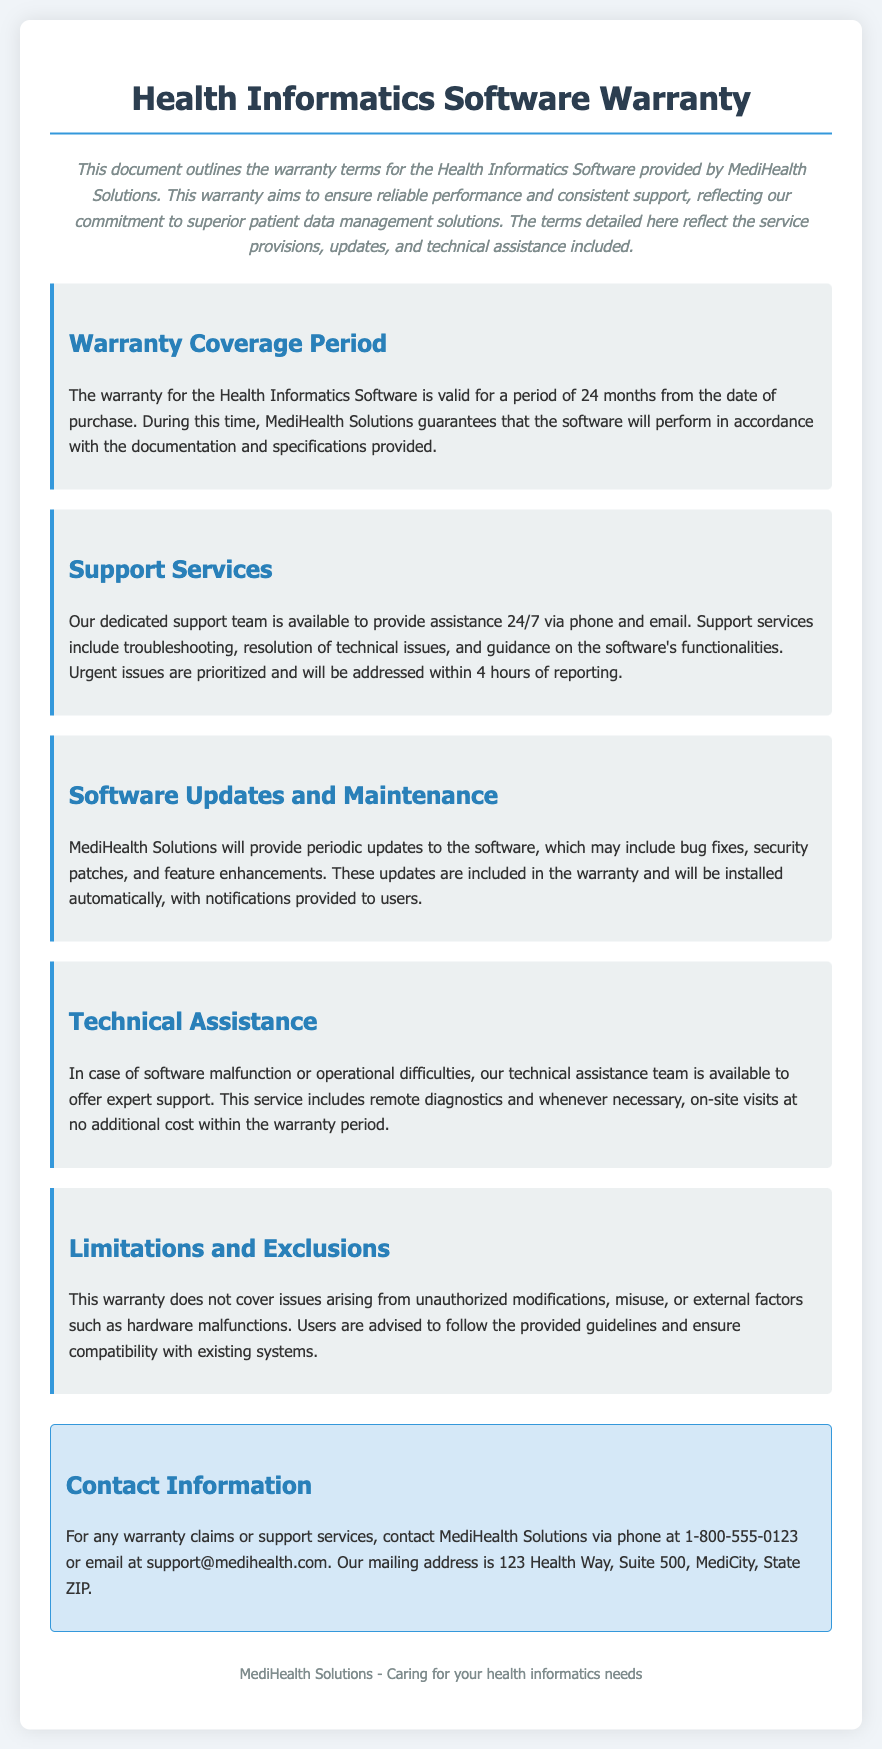what is the warranty coverage period? The warranty is valid for a period of 24 months from the date of purchase.
Answer: 24 months what type of support is available? The document states that support services include troubleshooting, resolution of technical issues, and guidance on the software's functionalities.
Answer: 24/7 support how quickly will urgent issues be addressed? Urgent issues are prioritized and will be addressed within 4 hours of reporting.
Answer: 4 hours what updates are included in the warranty? The warranty includes periodic updates that may consist of bug fixes, security patches, and feature enhancements.
Answer: Software updates what is not covered by the warranty? This warranty does not cover issues arising from unauthorized modifications, misuse, or external factors.
Answer: Unauthorized modifications what kind of assistance is provided for software malfunction? Technical assistance includes remote diagnostics and on-site visits at no additional cost within the warranty period.
Answer: Technical assistance where can you contact for warranty claims? For warranty claims, you can contact MediHealth Solutions via phone or email as specified in the contact information.
Answer: Phone or email what is included with software updates? Updates include bug fixes, security patches, and feature enhancements.
Answer: Bug fixes and security patches what company's warranty is this document outlining? This document outlines the warranty terms for the Health Informatics Software provided by MediHealth Solutions.
Answer: MediHealth Solutions 